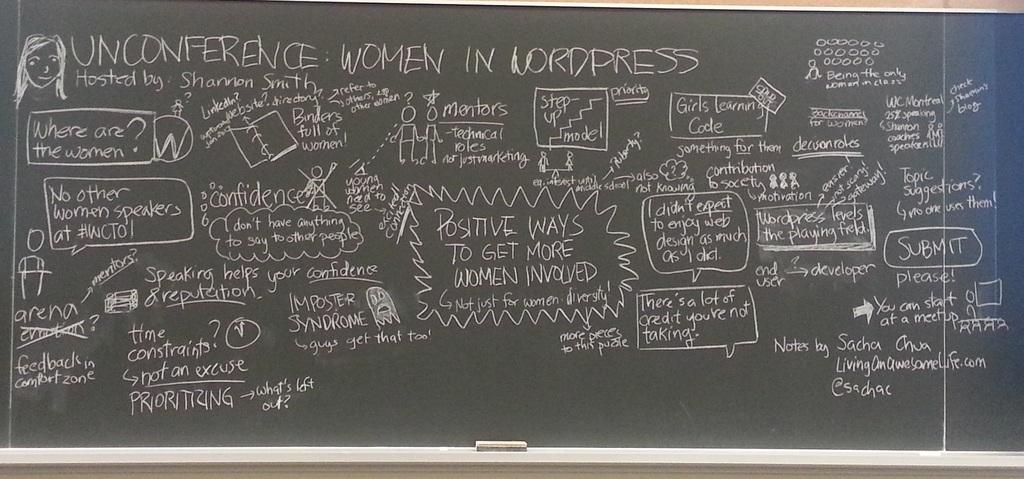<image>
Describe the image concisely. a chalkboard with the word unconference on it 